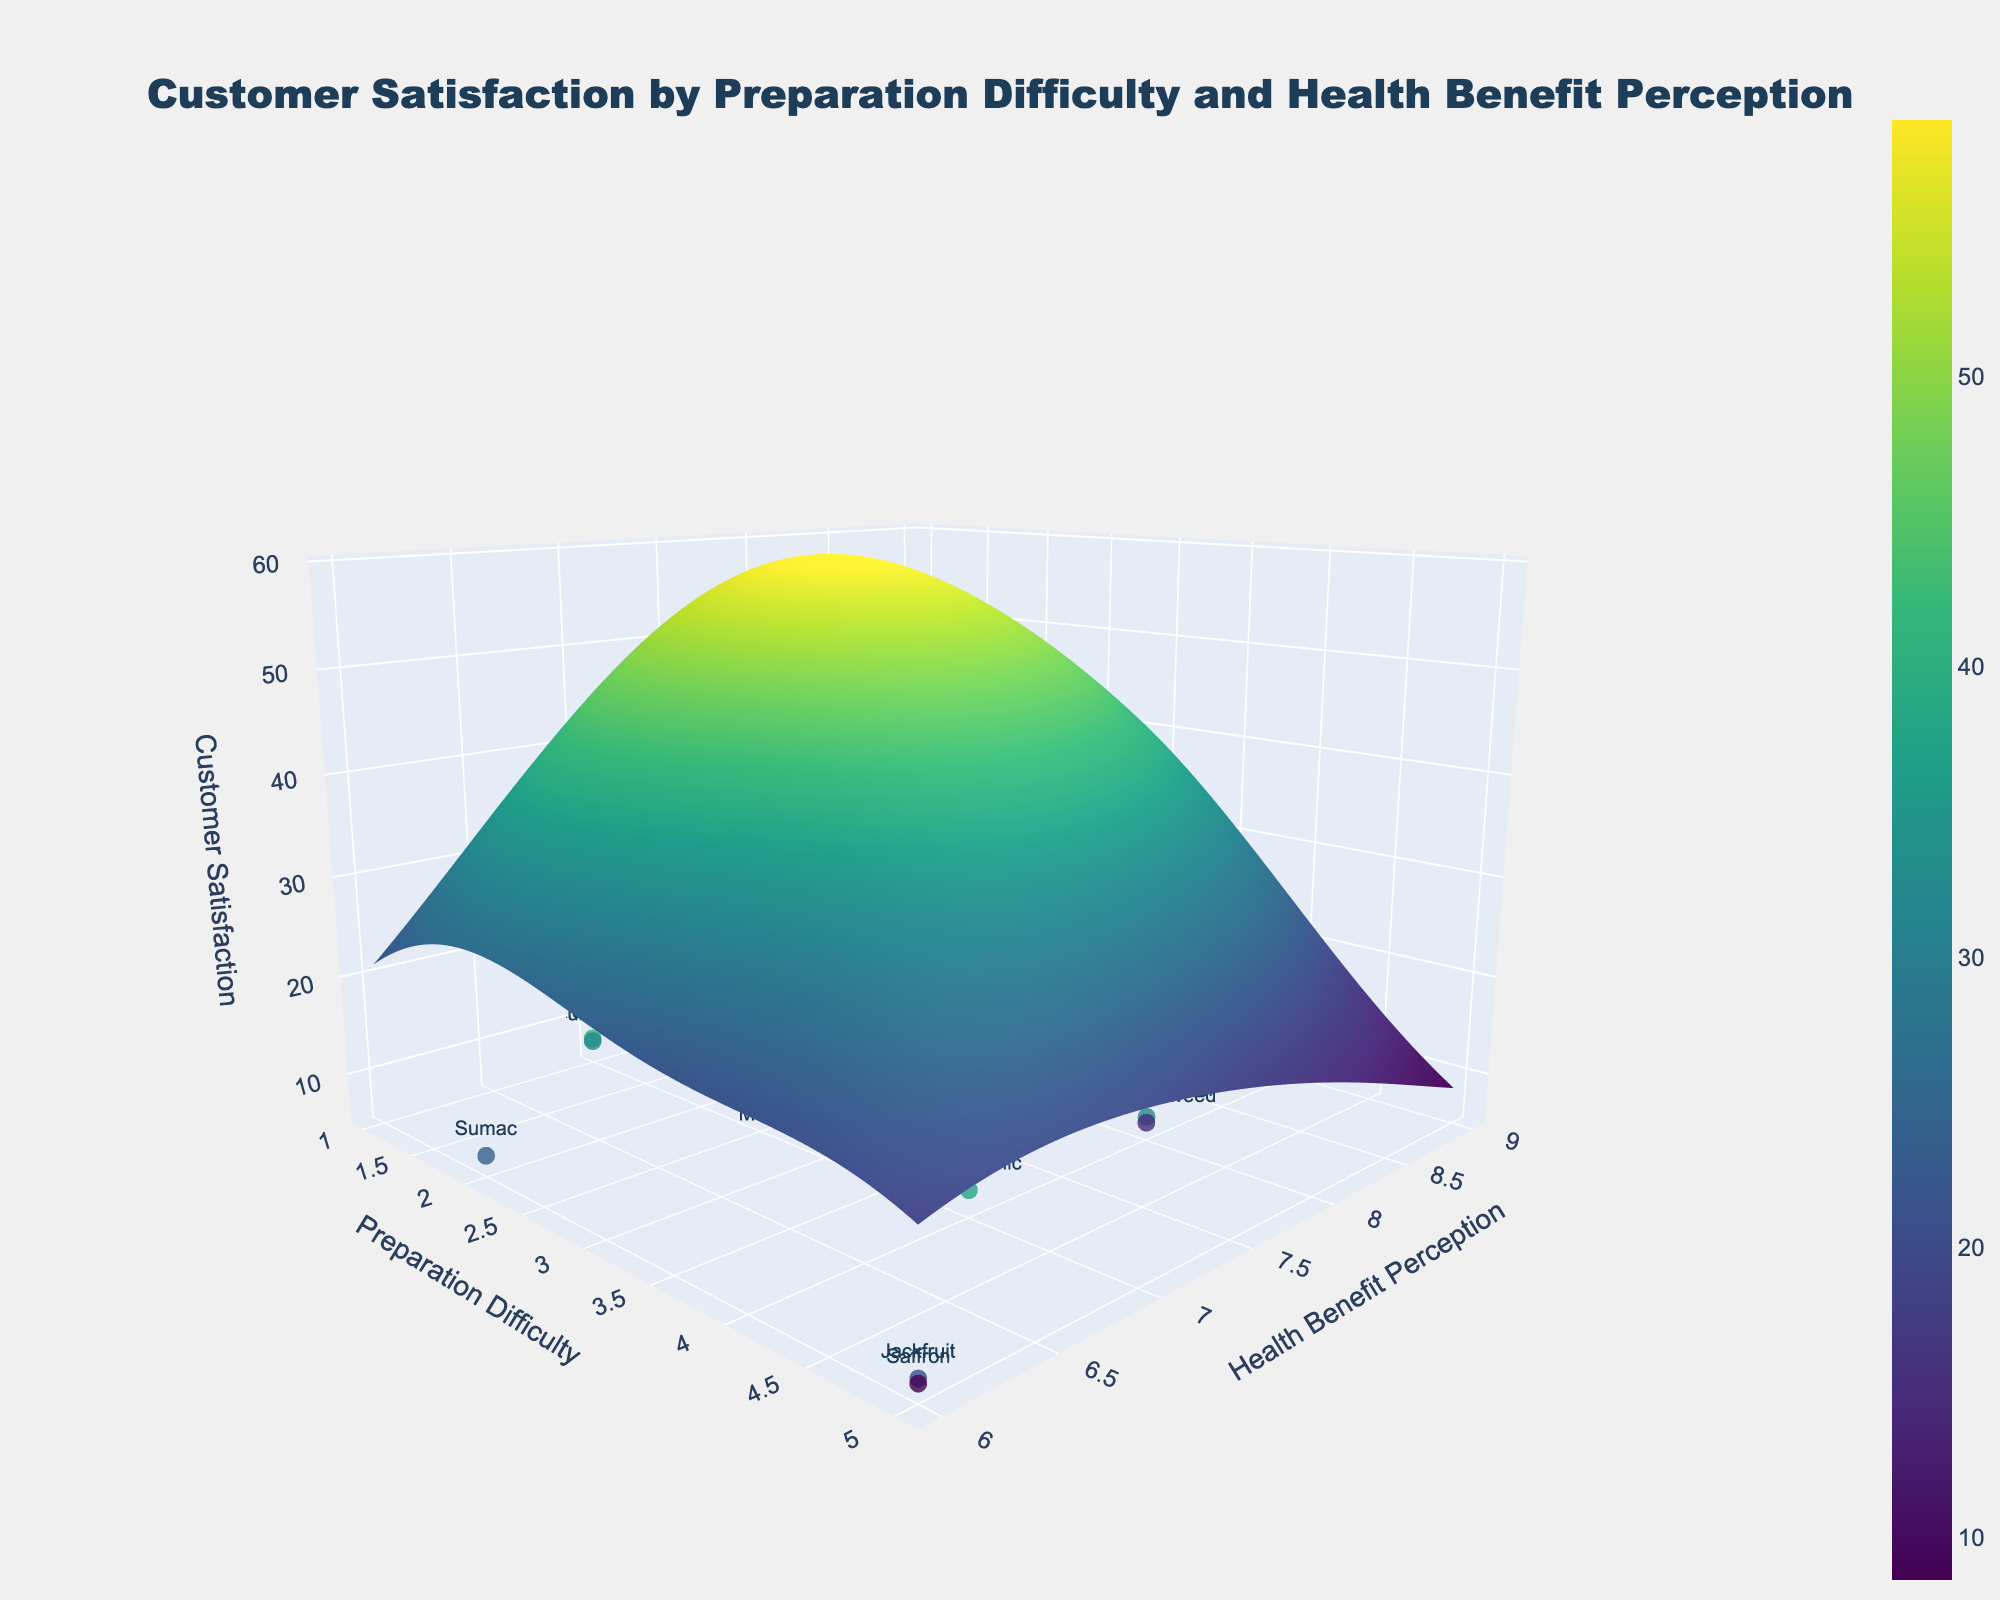How many unique ingredients are represented by markers on the plot? Check the number of individual markers labeled with ingredient names.
Answer: 19 What is the title of this plot? The title is generally found at the top center of the plot. In this plot, it states the focus is on customer satisfaction by preparation difficulty and health benefit perception.
Answer: Customer Satisfaction by Preparation Difficulty and Health Benefit Perception Which ingredient has the lowest preparation difficulty but is perceived to have high health benefits? Locate the marker positioned at the lowest value on the preparation difficulty axis and check its label. Match this with high values on the health benefit perception axis.
Answer: Chia Seeds Which ingredient shows the highest customer satisfaction rating, and what are its corresponding preparation difficulty and health benefit perception values? Identify the marker with the highest z-axis value (customer satisfaction). Check the x and y values for preparation difficulty and health benefit perception at this marker's position.
Answer: Chia Seeds, Preparation Difficulty: 1, Health Benefit Perception: 9 How does customer satisfaction change as preparation difficulty increases from 1 to 5 while keeping health benefit perception constant at 8? Observe the trend of the surface plot as you move along the preparation difficulty axis from 1 to 5 with health benefit perception fixed at 8. Note the overall surface contour changes.
Answer: Generally decreases What region on the plot shows the lowest customer satisfaction, considering both preparation difficulty and health benefit perception? Identify the lowest point on the z-axis (customer satisfaction) by examining the surface plot color gradients, with darker or less saturated colors representing low satisfaction.
Answer: Higher preparation difficulty (around 5) and lower health benefit perception (around 6) Is there a noticeable trend between health benefit perception and customer satisfaction for moderate preparation difficulty (e.g., around 3)? Examine the line on the surface plot where preparation difficulty remains around 3 and note if there's an upward or downward trend in the z-axis values.
Answer: Yes, an upward trend Which ingredients with preparation difficulty levels of 4 have customer satisfaction ratings above 7? Look for markers on the plot at preparation difficulty level 4 and note the z-axis values. Check if the customer satisfaction is above 7 and list the ingredient names.
Answer: Matcha Powder, Black Garlic Are there any ingredients with both high preparation difficulty and high customer satisfaction? Scan the plot area for higher preparation difficulty (4-5) and see if any markers also represent high customer satisfaction values (above 7).
Answer: No Comparing ingredients with a preparation difficulty of 2, which one has higher customer satisfaction: Sumac or Quinoa? Focus on the markers at a preparation difficulty of 2. Compare the z-axis values for Sumac and Quinoa.
Answer: Quinoa 